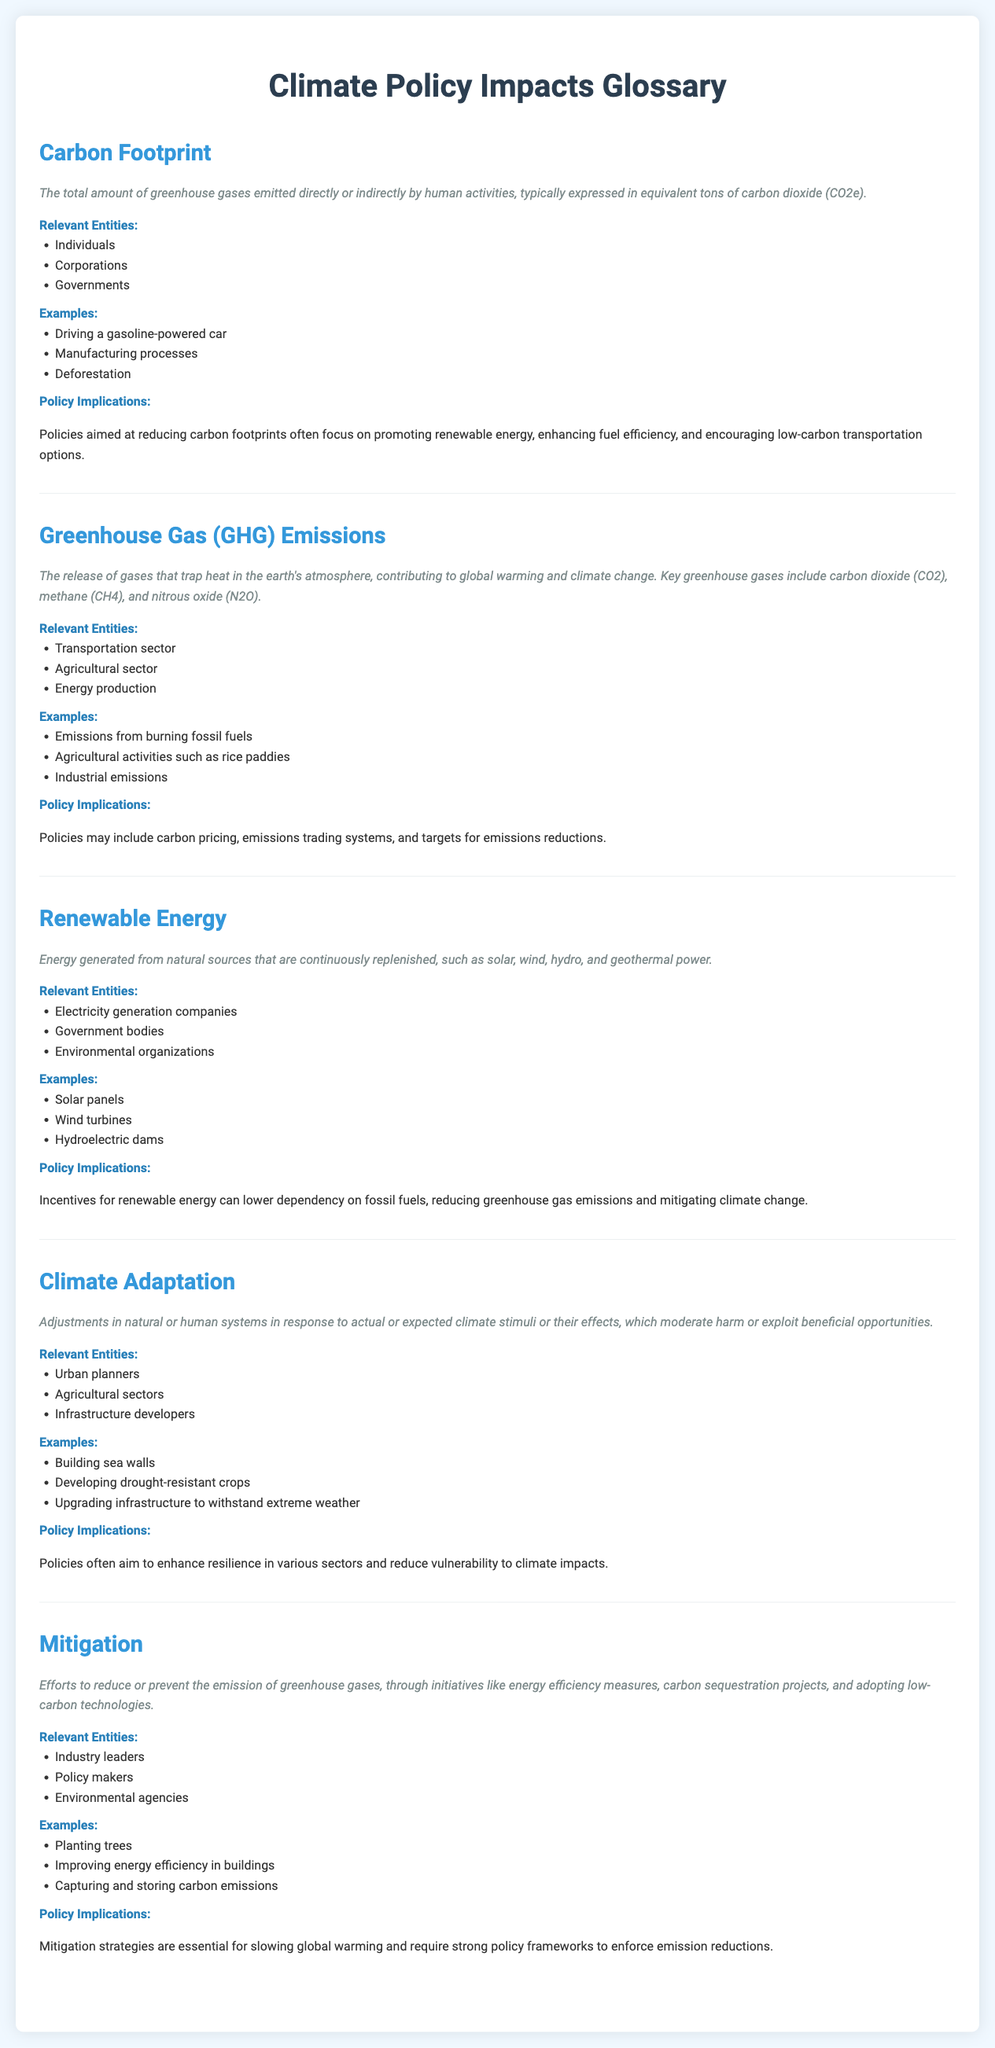What is the total amount of greenhouse gases emitted? The total amount is referred to as the carbon footprint and is expressed in equivalent tons of carbon dioxide (CO2e).
Answer: CO2e What is one key greenhouse gas mentioned? The document lists carbon dioxide (CO2), methane (CH4), and nitrous oxide (N2O) as key greenhouse gases.
Answer: Carbon dioxide What are the relevant entities for renewable energy? The relevant entities include electricity generation companies, government bodies, and environmental organizations.
Answer: Electricity generation companies What is an example of climate adaptation? One of the examples of climate adaptation mentioned is building sea walls.
Answer: Building sea walls What are two examples of mitigation efforts? The examples include planting trees and improving energy efficiency in buildings.
Answer: Planting trees, improving energy efficiency What is a significant policy implication related to carbon footprints? Policies aimed at reducing carbon footprints focus on promoting renewable energy.
Answer: Promoting renewable energy What is defined as energy generated from continuously replenished natural sources? This type of energy is defined as renewable energy.
Answer: Renewable energy Which sector is relevant for greenhouse gas emissions? The transportation sector is listed as a relevant sector for greenhouse gas emissions.
Answer: Transportation sector 